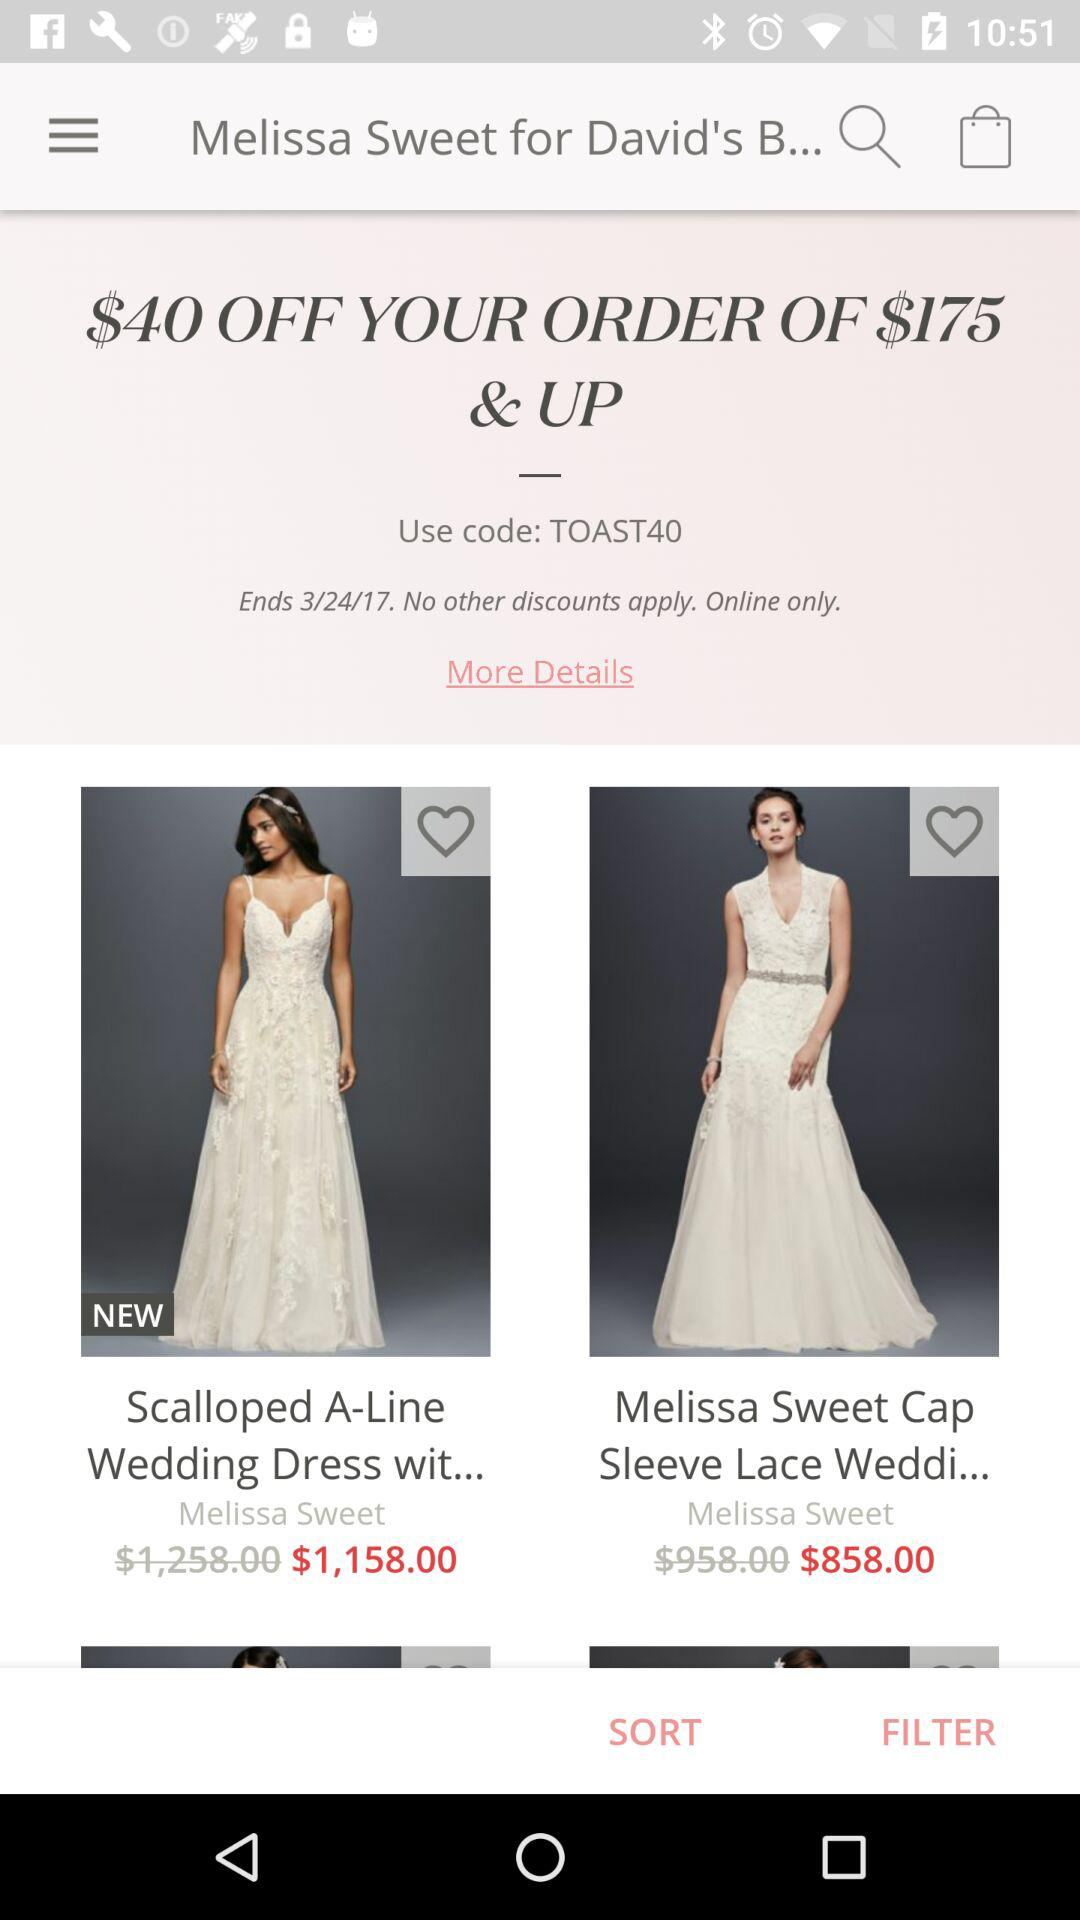How much money is off on orders of $175 and up? On orders of $175 and up, $40 is off. 